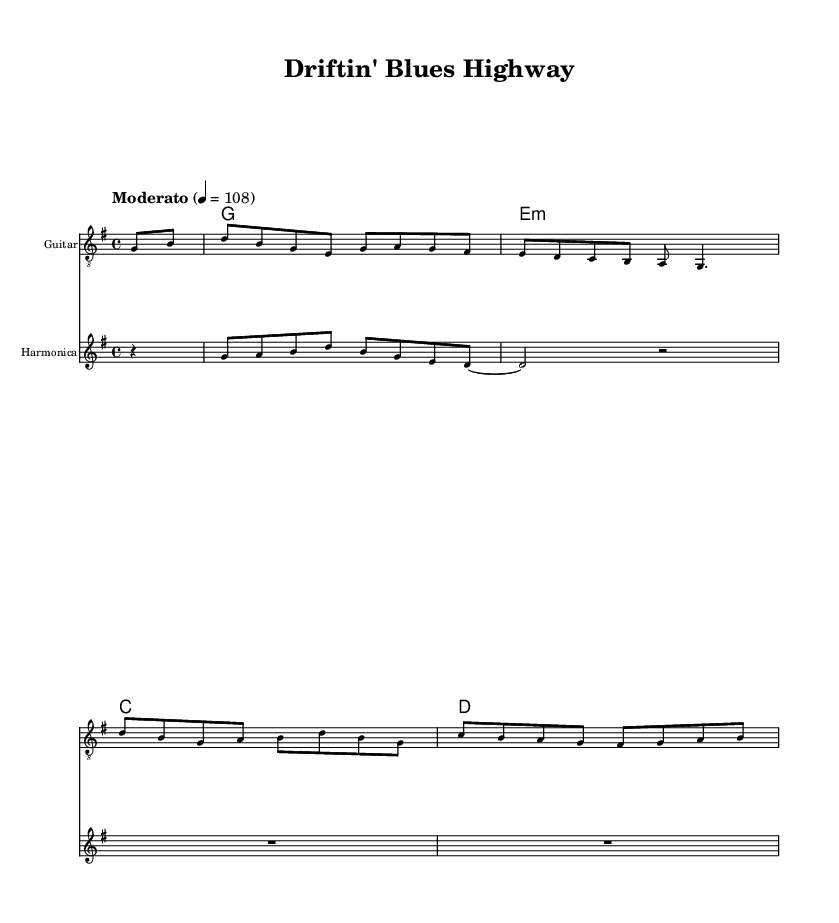What is the key signature of this music? The key signature indicates that the piece is in G major, which has one sharp (F#). This can be identified at the beginning of the music score, right after the clef.
Answer: G major What is the time signature of this piece? The time signature for this piece is 4/4, which can be found at the beginning of the score. It indicates that there are four beats in each measure, and the quarter note receives one beat.
Answer: 4/4 What is the tempo marking for this music? The tempo marking for this piece is "Moderato", with a metronome marking of 108 beats per minute. This is indicated at the start of the score following the time signature and key signature.
Answer: Moderato How many measures are in the guitar part? To find the number of measures in the guitar part, count the number of bars in the staff. The guitar part contains eight measures based on the rhythmic grouping.
Answer: Eight What instruments are used in this fusion piece? The score lists two instruments: the guitar and the harmonica. This is noted at the start of each corresponding staff and gives insight into the instrumentation for this fusion.
Answer: Guitar and harmonica What type of chords are played under the guitar part? The guitar part primarily includes major and minor chords, specifically G, E minor, C, and D. This can be determined by looking at the chord symbols notated above the staff in the score.
Answer: G, E minor, C, D What style of music does this piece incorporate? The piece incorporates jazz-folk fusion, characterized by its blend of acoustic guitar and harmonica elements. This style is indicated by the fusion concept and the instrumentation used in the score.
Answer: Jazz-folk fusion 